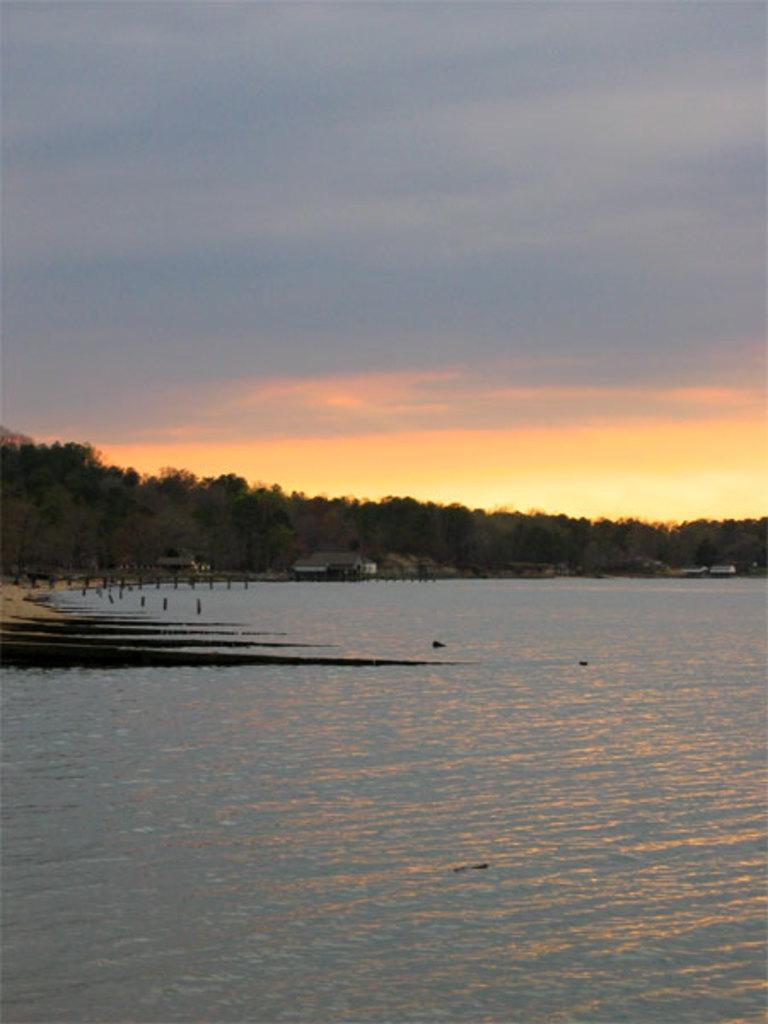What is in the foreground of the image? There is water in the foreground of the image. What can be seen in the middle of the image? There are many trees in the middle of the image. What is visible in the background of the image? The sky is visible in the background of the image. What type of mask can be seen hanging from the trees in the image? There are no masks present in the image; it features water, trees, and the sky. What songs can be heard coming from the trees in the image? There is no indication in the image that songs are being played or sung by the trees, as trees do not have the ability to produce music. 